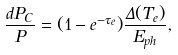<formula> <loc_0><loc_0><loc_500><loc_500>\frac { d P _ { C } } { P } = ( 1 - e ^ { - \tau _ { e } } ) \frac { \Delta ( T _ { e } ) } { E _ { p h } } ,</formula> 